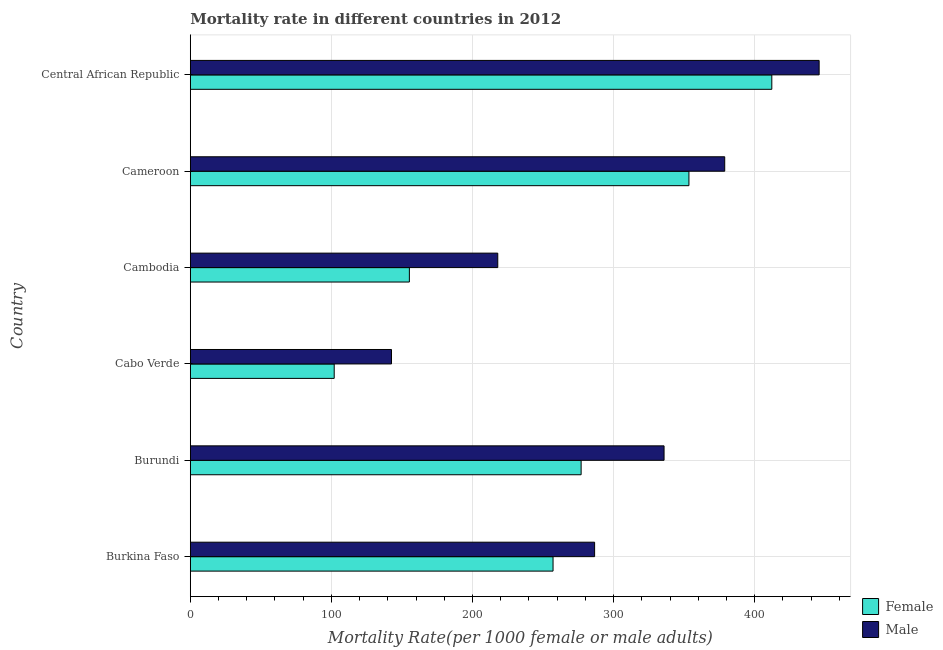How many bars are there on the 6th tick from the top?
Your response must be concise. 2. What is the label of the 1st group of bars from the top?
Your response must be concise. Central African Republic. In how many cases, is the number of bars for a given country not equal to the number of legend labels?
Your answer should be compact. 0. What is the female mortality rate in Cameroon?
Ensure brevity in your answer.  353.41. Across all countries, what is the maximum female mortality rate?
Provide a short and direct response. 412.16. Across all countries, what is the minimum male mortality rate?
Make the answer very short. 142.6. In which country was the male mortality rate maximum?
Provide a short and direct response. Central African Republic. In which country was the female mortality rate minimum?
Offer a very short reply. Cabo Verde. What is the total male mortality rate in the graph?
Provide a succinct answer. 1807.35. What is the difference between the male mortality rate in Burundi and that in Cabo Verde?
Your response must be concise. 193.18. What is the difference between the female mortality rate in Central African Republic and the male mortality rate in Cabo Verde?
Your answer should be very brief. 269.55. What is the average male mortality rate per country?
Make the answer very short. 301.22. What is the difference between the male mortality rate and female mortality rate in Burundi?
Provide a short and direct response. 58.78. In how many countries, is the female mortality rate greater than 160 ?
Offer a very short reply. 4. What is the ratio of the female mortality rate in Burundi to that in Cameroon?
Provide a succinct answer. 0.78. Is the female mortality rate in Burundi less than that in Cambodia?
Provide a succinct answer. No. What is the difference between the highest and the second highest female mortality rate?
Ensure brevity in your answer.  58.74. What is the difference between the highest and the lowest male mortality rate?
Keep it short and to the point. 303.1. Is the sum of the male mortality rate in Cambodia and Cameroon greater than the maximum female mortality rate across all countries?
Keep it short and to the point. Yes. How many bars are there?
Keep it short and to the point. 12. Are all the bars in the graph horizontal?
Ensure brevity in your answer.  Yes. How many countries are there in the graph?
Give a very brief answer. 6. What is the difference between two consecutive major ticks on the X-axis?
Keep it short and to the point. 100. Are the values on the major ticks of X-axis written in scientific E-notation?
Your answer should be very brief. No. Does the graph contain any zero values?
Your answer should be very brief. No. Where does the legend appear in the graph?
Keep it short and to the point. Bottom right. What is the title of the graph?
Your answer should be compact. Mortality rate in different countries in 2012. What is the label or title of the X-axis?
Keep it short and to the point. Mortality Rate(per 1000 female or male adults). What is the Mortality Rate(per 1000 female or male adults) of Female in Burkina Faso?
Provide a succinct answer. 257.1. What is the Mortality Rate(per 1000 female or male adults) in Male in Burkina Faso?
Offer a terse response. 286.56. What is the Mortality Rate(per 1000 female or male adults) in Female in Burundi?
Provide a short and direct response. 277.01. What is the Mortality Rate(per 1000 female or male adults) of Male in Burundi?
Provide a short and direct response. 335.79. What is the Mortality Rate(per 1000 female or male adults) in Female in Cabo Verde?
Offer a terse response. 102. What is the Mortality Rate(per 1000 female or male adults) of Male in Cabo Verde?
Make the answer very short. 142.6. What is the Mortality Rate(per 1000 female or male adults) in Female in Cambodia?
Your answer should be very brief. 155.28. What is the Mortality Rate(per 1000 female or male adults) of Male in Cambodia?
Your answer should be compact. 217.92. What is the Mortality Rate(per 1000 female or male adults) in Female in Cameroon?
Ensure brevity in your answer.  353.41. What is the Mortality Rate(per 1000 female or male adults) in Male in Cameroon?
Keep it short and to the point. 378.78. What is the Mortality Rate(per 1000 female or male adults) in Female in Central African Republic?
Ensure brevity in your answer.  412.16. What is the Mortality Rate(per 1000 female or male adults) in Male in Central African Republic?
Offer a terse response. 445.7. Across all countries, what is the maximum Mortality Rate(per 1000 female or male adults) of Female?
Offer a very short reply. 412.16. Across all countries, what is the maximum Mortality Rate(per 1000 female or male adults) in Male?
Offer a terse response. 445.7. Across all countries, what is the minimum Mortality Rate(per 1000 female or male adults) in Female?
Offer a terse response. 102. Across all countries, what is the minimum Mortality Rate(per 1000 female or male adults) in Male?
Offer a terse response. 142.6. What is the total Mortality Rate(per 1000 female or male adults) in Female in the graph?
Your answer should be very brief. 1556.96. What is the total Mortality Rate(per 1000 female or male adults) of Male in the graph?
Your answer should be compact. 1807.35. What is the difference between the Mortality Rate(per 1000 female or male adults) of Female in Burkina Faso and that in Burundi?
Provide a succinct answer. -19.9. What is the difference between the Mortality Rate(per 1000 female or male adults) of Male in Burkina Faso and that in Burundi?
Keep it short and to the point. -49.22. What is the difference between the Mortality Rate(per 1000 female or male adults) in Female in Burkina Faso and that in Cabo Verde?
Make the answer very short. 155.11. What is the difference between the Mortality Rate(per 1000 female or male adults) of Male in Burkina Faso and that in Cabo Verde?
Ensure brevity in your answer.  143.96. What is the difference between the Mortality Rate(per 1000 female or male adults) of Female in Burkina Faso and that in Cambodia?
Your answer should be very brief. 101.82. What is the difference between the Mortality Rate(per 1000 female or male adults) of Male in Burkina Faso and that in Cambodia?
Your response must be concise. 68.64. What is the difference between the Mortality Rate(per 1000 female or male adults) of Female in Burkina Faso and that in Cameroon?
Give a very brief answer. -96.31. What is the difference between the Mortality Rate(per 1000 female or male adults) in Male in Burkina Faso and that in Cameroon?
Your answer should be very brief. -92.21. What is the difference between the Mortality Rate(per 1000 female or male adults) in Female in Burkina Faso and that in Central African Republic?
Offer a terse response. -155.05. What is the difference between the Mortality Rate(per 1000 female or male adults) in Male in Burkina Faso and that in Central African Republic?
Make the answer very short. -159.14. What is the difference between the Mortality Rate(per 1000 female or male adults) in Female in Burundi and that in Cabo Verde?
Your response must be concise. 175.01. What is the difference between the Mortality Rate(per 1000 female or male adults) of Male in Burundi and that in Cabo Verde?
Keep it short and to the point. 193.18. What is the difference between the Mortality Rate(per 1000 female or male adults) of Female in Burundi and that in Cambodia?
Keep it short and to the point. 121.73. What is the difference between the Mortality Rate(per 1000 female or male adults) in Male in Burundi and that in Cambodia?
Your response must be concise. 117.86. What is the difference between the Mortality Rate(per 1000 female or male adults) of Female in Burundi and that in Cameroon?
Your response must be concise. -76.41. What is the difference between the Mortality Rate(per 1000 female or male adults) of Male in Burundi and that in Cameroon?
Offer a terse response. -42.99. What is the difference between the Mortality Rate(per 1000 female or male adults) in Female in Burundi and that in Central African Republic?
Offer a very short reply. -135.15. What is the difference between the Mortality Rate(per 1000 female or male adults) of Male in Burundi and that in Central African Republic?
Your response must be concise. -109.92. What is the difference between the Mortality Rate(per 1000 female or male adults) in Female in Cabo Verde and that in Cambodia?
Offer a very short reply. -53.28. What is the difference between the Mortality Rate(per 1000 female or male adults) in Male in Cabo Verde and that in Cambodia?
Your answer should be compact. -75.32. What is the difference between the Mortality Rate(per 1000 female or male adults) of Female in Cabo Verde and that in Cameroon?
Provide a short and direct response. -251.41. What is the difference between the Mortality Rate(per 1000 female or male adults) of Male in Cabo Verde and that in Cameroon?
Give a very brief answer. -236.17. What is the difference between the Mortality Rate(per 1000 female or male adults) of Female in Cabo Verde and that in Central African Republic?
Ensure brevity in your answer.  -310.16. What is the difference between the Mortality Rate(per 1000 female or male adults) of Male in Cabo Verde and that in Central African Republic?
Ensure brevity in your answer.  -303.1. What is the difference between the Mortality Rate(per 1000 female or male adults) in Female in Cambodia and that in Cameroon?
Make the answer very short. -198.13. What is the difference between the Mortality Rate(per 1000 female or male adults) of Male in Cambodia and that in Cameroon?
Provide a succinct answer. -160.86. What is the difference between the Mortality Rate(per 1000 female or male adults) of Female in Cambodia and that in Central African Republic?
Make the answer very short. -256.88. What is the difference between the Mortality Rate(per 1000 female or male adults) in Male in Cambodia and that in Central African Republic?
Your response must be concise. -227.78. What is the difference between the Mortality Rate(per 1000 female or male adults) of Female in Cameroon and that in Central African Republic?
Your answer should be very brief. -58.74. What is the difference between the Mortality Rate(per 1000 female or male adults) in Male in Cameroon and that in Central African Republic?
Offer a very short reply. -66.92. What is the difference between the Mortality Rate(per 1000 female or male adults) in Female in Burkina Faso and the Mortality Rate(per 1000 female or male adults) in Male in Burundi?
Give a very brief answer. -78.68. What is the difference between the Mortality Rate(per 1000 female or male adults) of Female in Burkina Faso and the Mortality Rate(per 1000 female or male adults) of Male in Cabo Verde?
Provide a short and direct response. 114.5. What is the difference between the Mortality Rate(per 1000 female or male adults) in Female in Burkina Faso and the Mortality Rate(per 1000 female or male adults) in Male in Cambodia?
Your answer should be very brief. 39.18. What is the difference between the Mortality Rate(per 1000 female or male adults) in Female in Burkina Faso and the Mortality Rate(per 1000 female or male adults) in Male in Cameroon?
Keep it short and to the point. -121.67. What is the difference between the Mortality Rate(per 1000 female or male adults) of Female in Burkina Faso and the Mortality Rate(per 1000 female or male adults) of Male in Central African Republic?
Make the answer very short. -188.6. What is the difference between the Mortality Rate(per 1000 female or male adults) in Female in Burundi and the Mortality Rate(per 1000 female or male adults) in Male in Cabo Verde?
Give a very brief answer. 134.4. What is the difference between the Mortality Rate(per 1000 female or male adults) of Female in Burundi and the Mortality Rate(per 1000 female or male adults) of Male in Cambodia?
Make the answer very short. 59.09. What is the difference between the Mortality Rate(per 1000 female or male adults) in Female in Burundi and the Mortality Rate(per 1000 female or male adults) in Male in Cameroon?
Provide a succinct answer. -101.77. What is the difference between the Mortality Rate(per 1000 female or male adults) of Female in Burundi and the Mortality Rate(per 1000 female or male adults) of Male in Central African Republic?
Ensure brevity in your answer.  -168.69. What is the difference between the Mortality Rate(per 1000 female or male adults) in Female in Cabo Verde and the Mortality Rate(per 1000 female or male adults) in Male in Cambodia?
Your response must be concise. -115.92. What is the difference between the Mortality Rate(per 1000 female or male adults) of Female in Cabo Verde and the Mortality Rate(per 1000 female or male adults) of Male in Cameroon?
Your answer should be very brief. -276.78. What is the difference between the Mortality Rate(per 1000 female or male adults) of Female in Cabo Verde and the Mortality Rate(per 1000 female or male adults) of Male in Central African Republic?
Offer a very short reply. -343.7. What is the difference between the Mortality Rate(per 1000 female or male adults) in Female in Cambodia and the Mortality Rate(per 1000 female or male adults) in Male in Cameroon?
Your response must be concise. -223.5. What is the difference between the Mortality Rate(per 1000 female or male adults) of Female in Cambodia and the Mortality Rate(per 1000 female or male adults) of Male in Central African Republic?
Provide a succinct answer. -290.42. What is the difference between the Mortality Rate(per 1000 female or male adults) of Female in Cameroon and the Mortality Rate(per 1000 female or male adults) of Male in Central African Republic?
Your answer should be compact. -92.29. What is the average Mortality Rate(per 1000 female or male adults) of Female per country?
Offer a very short reply. 259.49. What is the average Mortality Rate(per 1000 female or male adults) in Male per country?
Offer a very short reply. 301.22. What is the difference between the Mortality Rate(per 1000 female or male adults) of Female and Mortality Rate(per 1000 female or male adults) of Male in Burkina Faso?
Offer a very short reply. -29.46. What is the difference between the Mortality Rate(per 1000 female or male adults) of Female and Mortality Rate(per 1000 female or male adults) of Male in Burundi?
Your answer should be compact. -58.78. What is the difference between the Mortality Rate(per 1000 female or male adults) of Female and Mortality Rate(per 1000 female or male adults) of Male in Cabo Verde?
Provide a succinct answer. -40.6. What is the difference between the Mortality Rate(per 1000 female or male adults) in Female and Mortality Rate(per 1000 female or male adults) in Male in Cambodia?
Your answer should be very brief. -62.64. What is the difference between the Mortality Rate(per 1000 female or male adults) in Female and Mortality Rate(per 1000 female or male adults) in Male in Cameroon?
Your answer should be compact. -25.36. What is the difference between the Mortality Rate(per 1000 female or male adults) of Female and Mortality Rate(per 1000 female or male adults) of Male in Central African Republic?
Make the answer very short. -33.54. What is the ratio of the Mortality Rate(per 1000 female or male adults) in Female in Burkina Faso to that in Burundi?
Your answer should be very brief. 0.93. What is the ratio of the Mortality Rate(per 1000 female or male adults) of Male in Burkina Faso to that in Burundi?
Give a very brief answer. 0.85. What is the ratio of the Mortality Rate(per 1000 female or male adults) in Female in Burkina Faso to that in Cabo Verde?
Offer a very short reply. 2.52. What is the ratio of the Mortality Rate(per 1000 female or male adults) of Male in Burkina Faso to that in Cabo Verde?
Offer a very short reply. 2.01. What is the ratio of the Mortality Rate(per 1000 female or male adults) in Female in Burkina Faso to that in Cambodia?
Offer a terse response. 1.66. What is the ratio of the Mortality Rate(per 1000 female or male adults) of Male in Burkina Faso to that in Cambodia?
Provide a short and direct response. 1.31. What is the ratio of the Mortality Rate(per 1000 female or male adults) of Female in Burkina Faso to that in Cameroon?
Give a very brief answer. 0.73. What is the ratio of the Mortality Rate(per 1000 female or male adults) in Male in Burkina Faso to that in Cameroon?
Offer a terse response. 0.76. What is the ratio of the Mortality Rate(per 1000 female or male adults) in Female in Burkina Faso to that in Central African Republic?
Provide a short and direct response. 0.62. What is the ratio of the Mortality Rate(per 1000 female or male adults) of Male in Burkina Faso to that in Central African Republic?
Ensure brevity in your answer.  0.64. What is the ratio of the Mortality Rate(per 1000 female or male adults) in Female in Burundi to that in Cabo Verde?
Your answer should be very brief. 2.72. What is the ratio of the Mortality Rate(per 1000 female or male adults) of Male in Burundi to that in Cabo Verde?
Ensure brevity in your answer.  2.35. What is the ratio of the Mortality Rate(per 1000 female or male adults) in Female in Burundi to that in Cambodia?
Provide a succinct answer. 1.78. What is the ratio of the Mortality Rate(per 1000 female or male adults) of Male in Burundi to that in Cambodia?
Make the answer very short. 1.54. What is the ratio of the Mortality Rate(per 1000 female or male adults) in Female in Burundi to that in Cameroon?
Offer a very short reply. 0.78. What is the ratio of the Mortality Rate(per 1000 female or male adults) in Male in Burundi to that in Cameroon?
Give a very brief answer. 0.89. What is the ratio of the Mortality Rate(per 1000 female or male adults) in Female in Burundi to that in Central African Republic?
Your answer should be compact. 0.67. What is the ratio of the Mortality Rate(per 1000 female or male adults) of Male in Burundi to that in Central African Republic?
Ensure brevity in your answer.  0.75. What is the ratio of the Mortality Rate(per 1000 female or male adults) of Female in Cabo Verde to that in Cambodia?
Offer a terse response. 0.66. What is the ratio of the Mortality Rate(per 1000 female or male adults) of Male in Cabo Verde to that in Cambodia?
Make the answer very short. 0.65. What is the ratio of the Mortality Rate(per 1000 female or male adults) of Female in Cabo Verde to that in Cameroon?
Ensure brevity in your answer.  0.29. What is the ratio of the Mortality Rate(per 1000 female or male adults) of Male in Cabo Verde to that in Cameroon?
Give a very brief answer. 0.38. What is the ratio of the Mortality Rate(per 1000 female or male adults) in Female in Cabo Verde to that in Central African Republic?
Provide a succinct answer. 0.25. What is the ratio of the Mortality Rate(per 1000 female or male adults) in Male in Cabo Verde to that in Central African Republic?
Offer a terse response. 0.32. What is the ratio of the Mortality Rate(per 1000 female or male adults) of Female in Cambodia to that in Cameroon?
Your response must be concise. 0.44. What is the ratio of the Mortality Rate(per 1000 female or male adults) of Male in Cambodia to that in Cameroon?
Keep it short and to the point. 0.58. What is the ratio of the Mortality Rate(per 1000 female or male adults) in Female in Cambodia to that in Central African Republic?
Provide a short and direct response. 0.38. What is the ratio of the Mortality Rate(per 1000 female or male adults) of Male in Cambodia to that in Central African Republic?
Keep it short and to the point. 0.49. What is the ratio of the Mortality Rate(per 1000 female or male adults) of Female in Cameroon to that in Central African Republic?
Offer a terse response. 0.86. What is the ratio of the Mortality Rate(per 1000 female or male adults) of Male in Cameroon to that in Central African Republic?
Provide a succinct answer. 0.85. What is the difference between the highest and the second highest Mortality Rate(per 1000 female or male adults) of Female?
Provide a succinct answer. 58.74. What is the difference between the highest and the second highest Mortality Rate(per 1000 female or male adults) in Male?
Offer a very short reply. 66.92. What is the difference between the highest and the lowest Mortality Rate(per 1000 female or male adults) of Female?
Offer a terse response. 310.16. What is the difference between the highest and the lowest Mortality Rate(per 1000 female or male adults) in Male?
Your answer should be very brief. 303.1. 